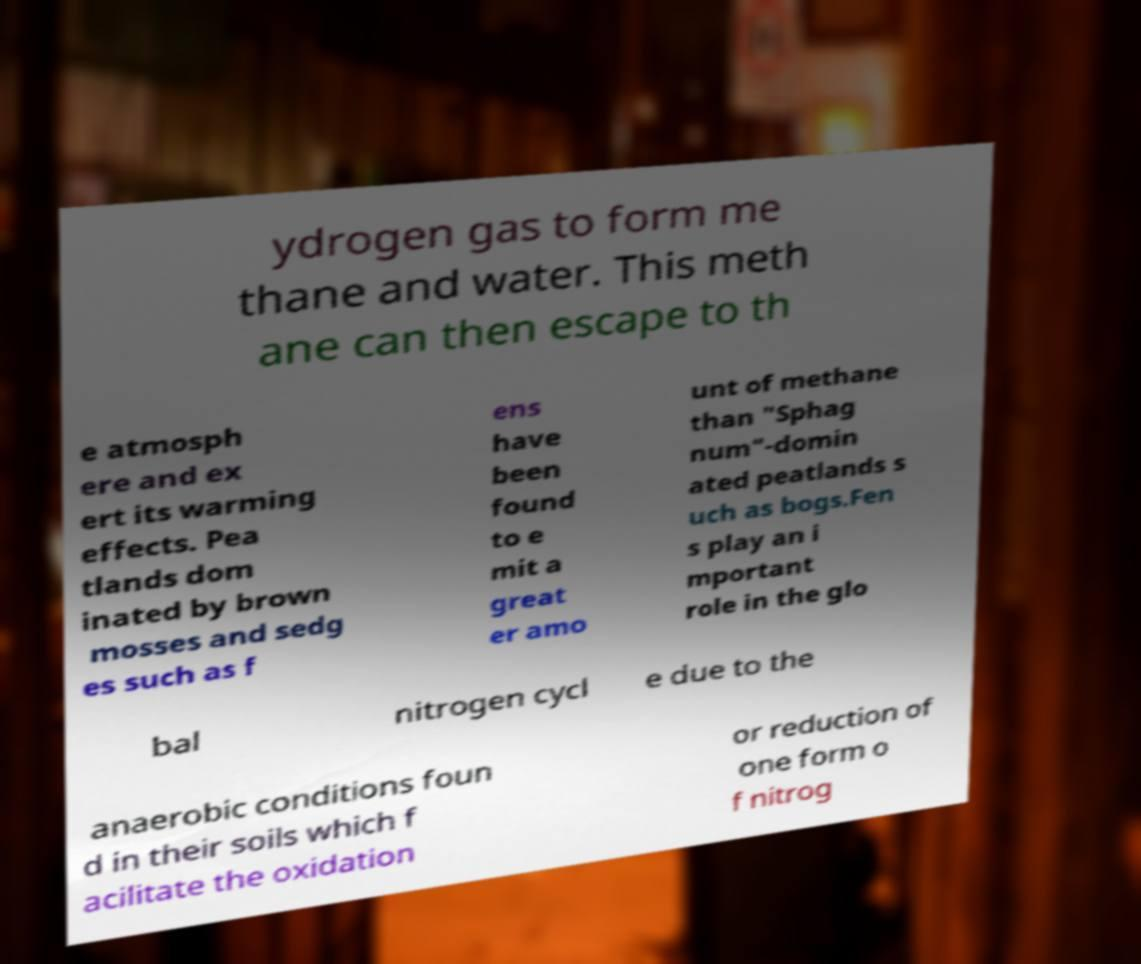What messages or text are displayed in this image? I need them in a readable, typed format. ydrogen gas to form me thane and water. This meth ane can then escape to th e atmosph ere and ex ert its warming effects. Pea tlands dom inated by brown mosses and sedg es such as f ens have been found to e mit a great er amo unt of methane than "Sphag num"-domin ated peatlands s uch as bogs.Fen s play an i mportant role in the glo bal nitrogen cycl e due to the anaerobic conditions foun d in their soils which f acilitate the oxidation or reduction of one form o f nitrog 